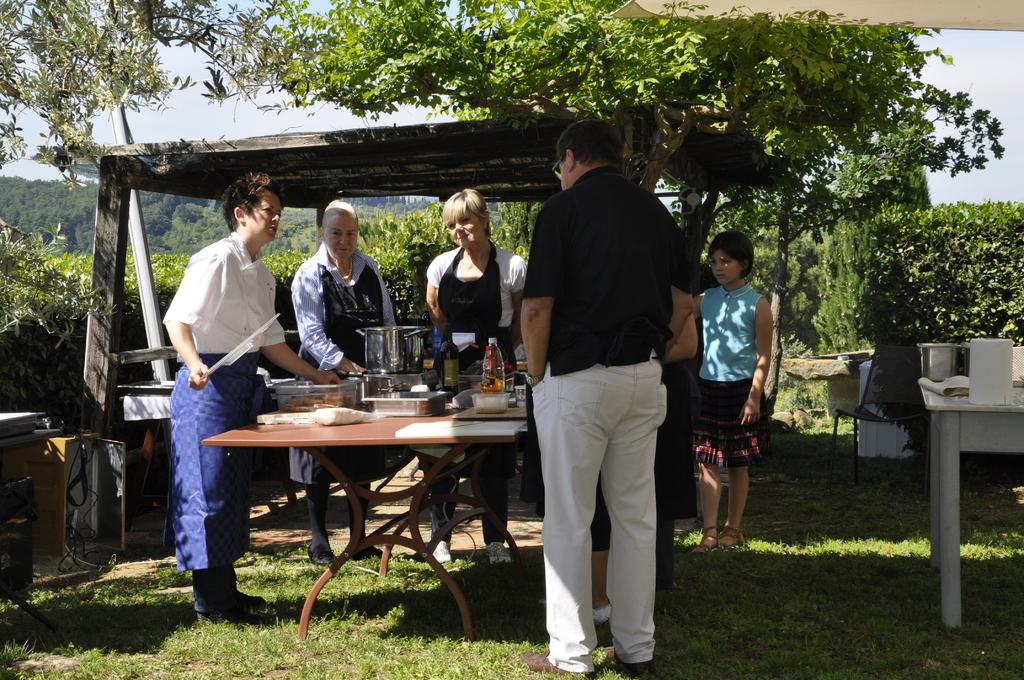What is happening in the image involving the people? The people are standing around a table. What objects can be seen on the table? There are vessels, a bottle, a box, and food on the table. Can you describe the table's location in the image? There is a table on the right side of the image. What can be seen in the background of the image? There are trees in the background. What type of slope can be seen in the image? There is no slope present in the image; it features people standing around a table with various objects on it. What kind of plants are growing on the table? There are no plants growing on the table in the image; it contains vessels, a bottle, a box, and food. 